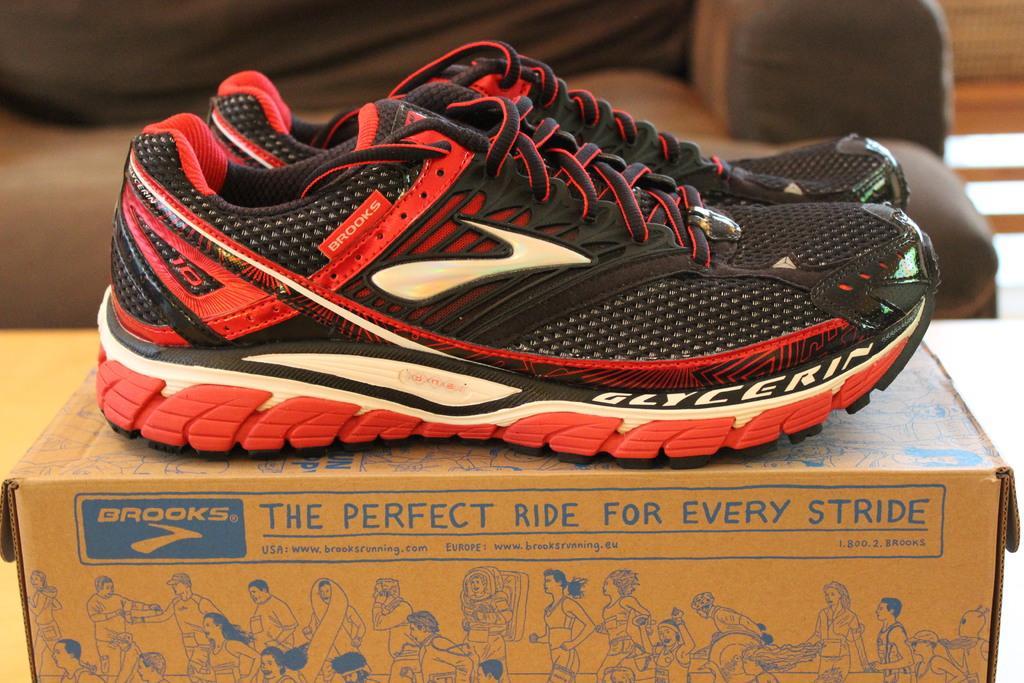Please provide a concise description of this image. In this image we can see a pair of shoes on the cardboard box which is on the table. In the background we can see the sofa. 